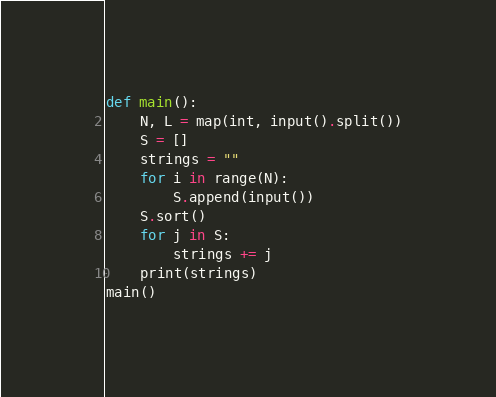<code> <loc_0><loc_0><loc_500><loc_500><_Python_>def main():
    N, L = map(int, input().split())
    S = []
    strings = ""
    for i in range(N):
        S.append(input())
    S.sort()
    for j in S:
        strings += j
    print(strings)
main()
</code> 